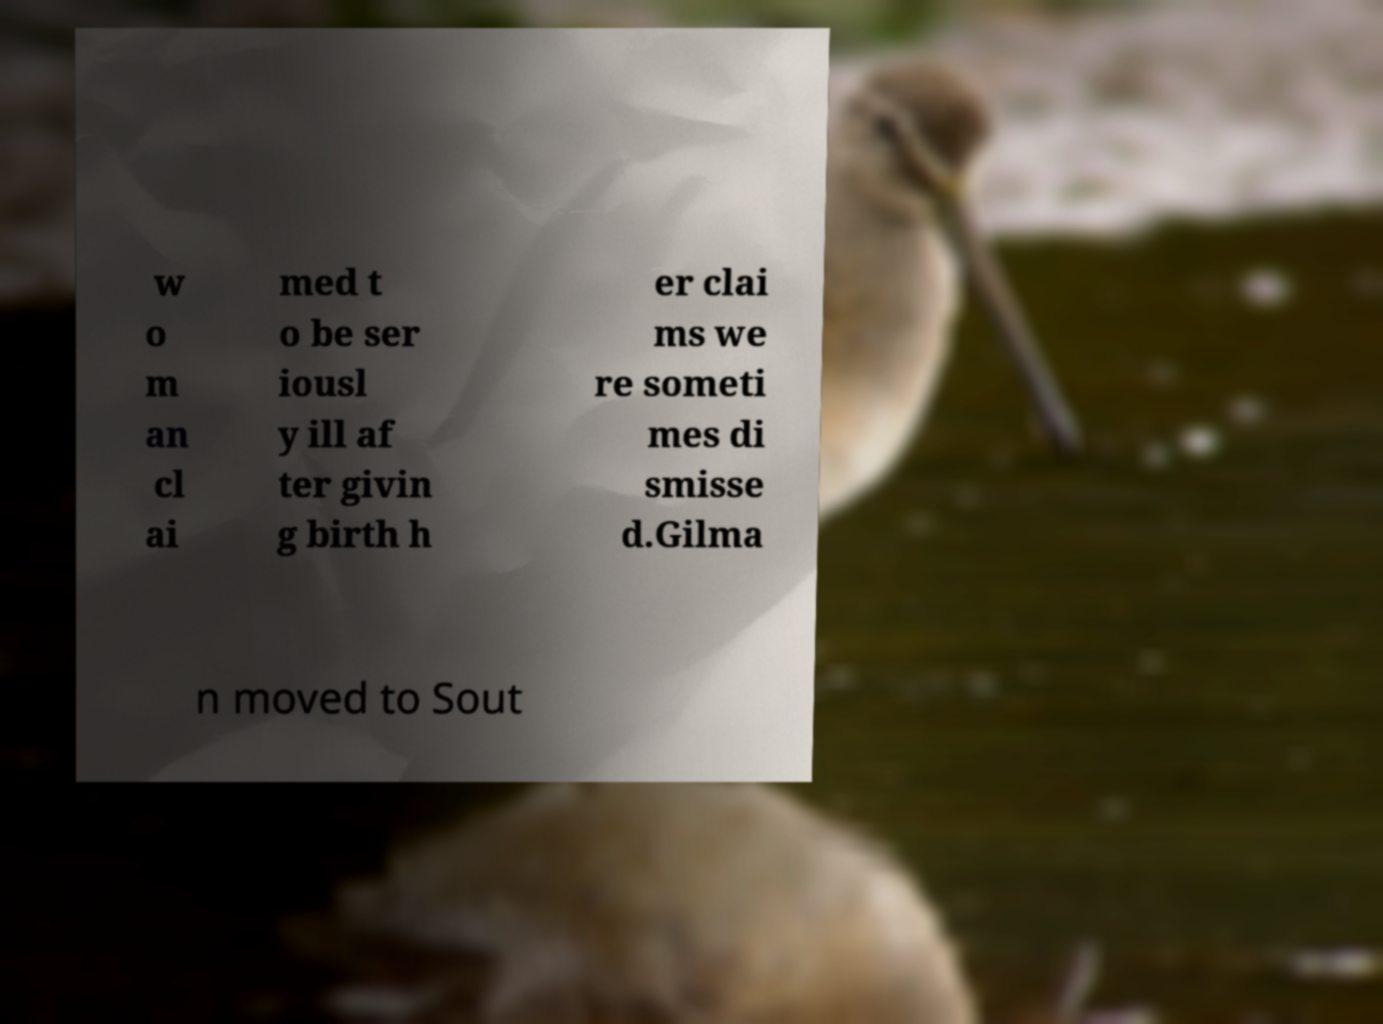There's text embedded in this image that I need extracted. Can you transcribe it verbatim? w o m an cl ai med t o be ser iousl y ill af ter givin g birth h er clai ms we re someti mes di smisse d.Gilma n moved to Sout 